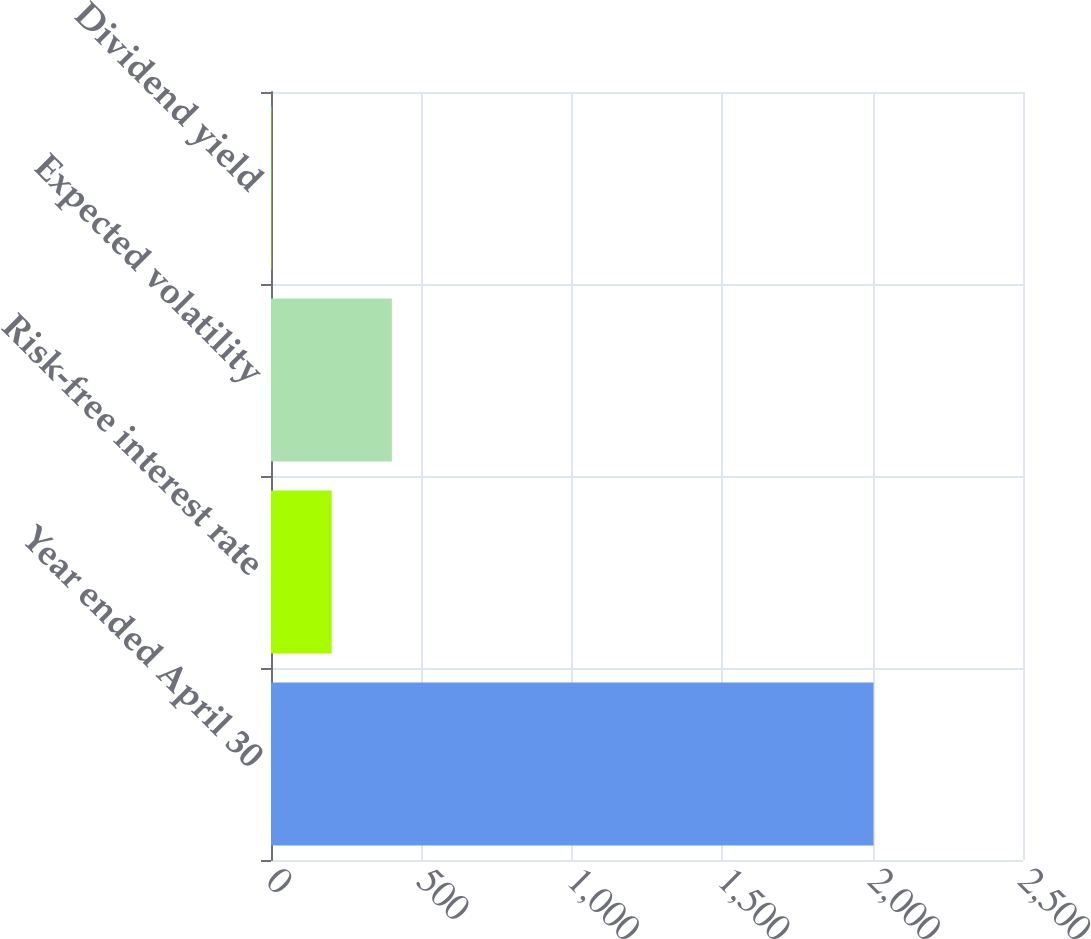Convert chart to OTSL. <chart><loc_0><loc_0><loc_500><loc_500><bar_chart><fcel>Year ended April 30<fcel>Risk-free interest rate<fcel>Expected volatility<fcel>Dividend yield<nl><fcel>2003<fcel>201.65<fcel>401.8<fcel>1.5<nl></chart> 